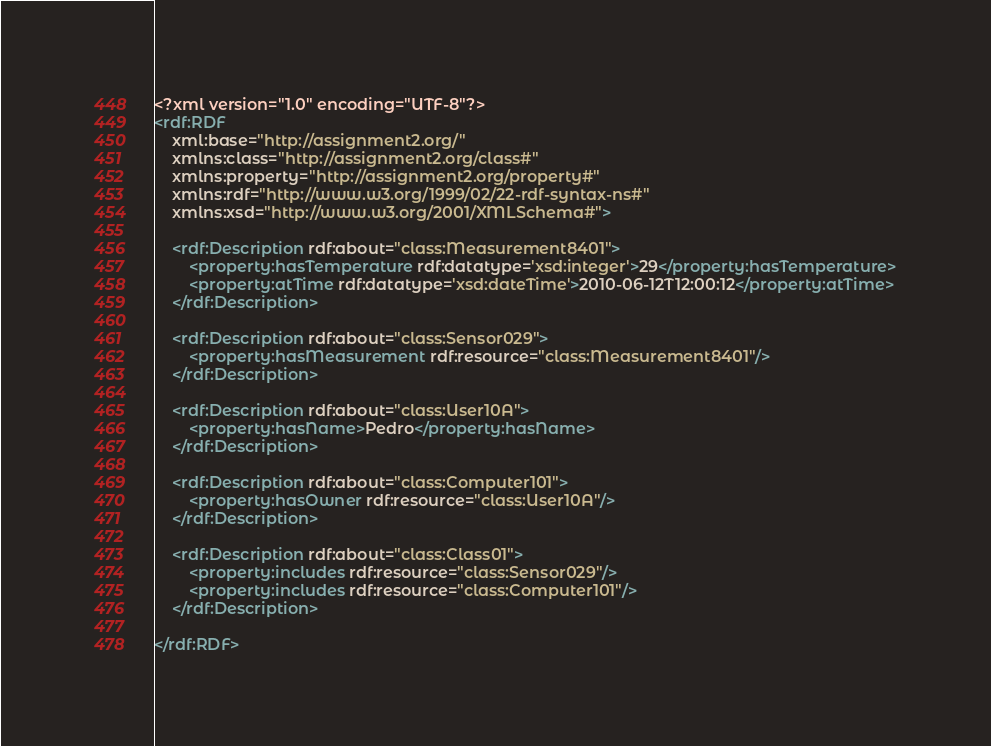<code> <loc_0><loc_0><loc_500><loc_500><_XML_><?xml version="1.0" encoding="UTF-8"?>
<rdf:RDF
	xml:base="http://assignment2.org/"
	xmlns:class="http://assignment2.org/class#"
	xmlns:property="http://assignment2.org/property#"
	xmlns:rdf="http://www.w3.org/1999/02/22-rdf-syntax-ns#"
	xmlns:xsd="http://www.w3.org/2001/XMLSchema#">

	<rdf:Description rdf:about="class:Measurement8401">
	    <property:hasTemperature rdf:datatype='xsd:integer'>29</property:hasTemperature>
		<property:atTime rdf:datatype='xsd:dateTime'>2010-06-12T12:00:12</property:atTime>
	</rdf:Description>

	<rdf:Description rdf:about="class:Sensor029">
		<property:hasMeasurement rdf:resource="class:Measurement8401"/>
	</rdf:Description>

	<rdf:Description rdf:about="class:User10A">
		<property:hasName>Pedro</property:hasName>
	</rdf:Description>
	
	<rdf:Description rdf:about="class:Computer101">
		<property:hasOwner rdf:resource="class:User10A"/>
	</rdf:Description>
	
	<rdf:Description rdf:about="class:Class01">
		<property:includes rdf:resource="class:Sensor029"/>
		<property:includes rdf:resource="class:Computer101"/>
	</rdf:Description>
	
</rdf:RDF></code> 